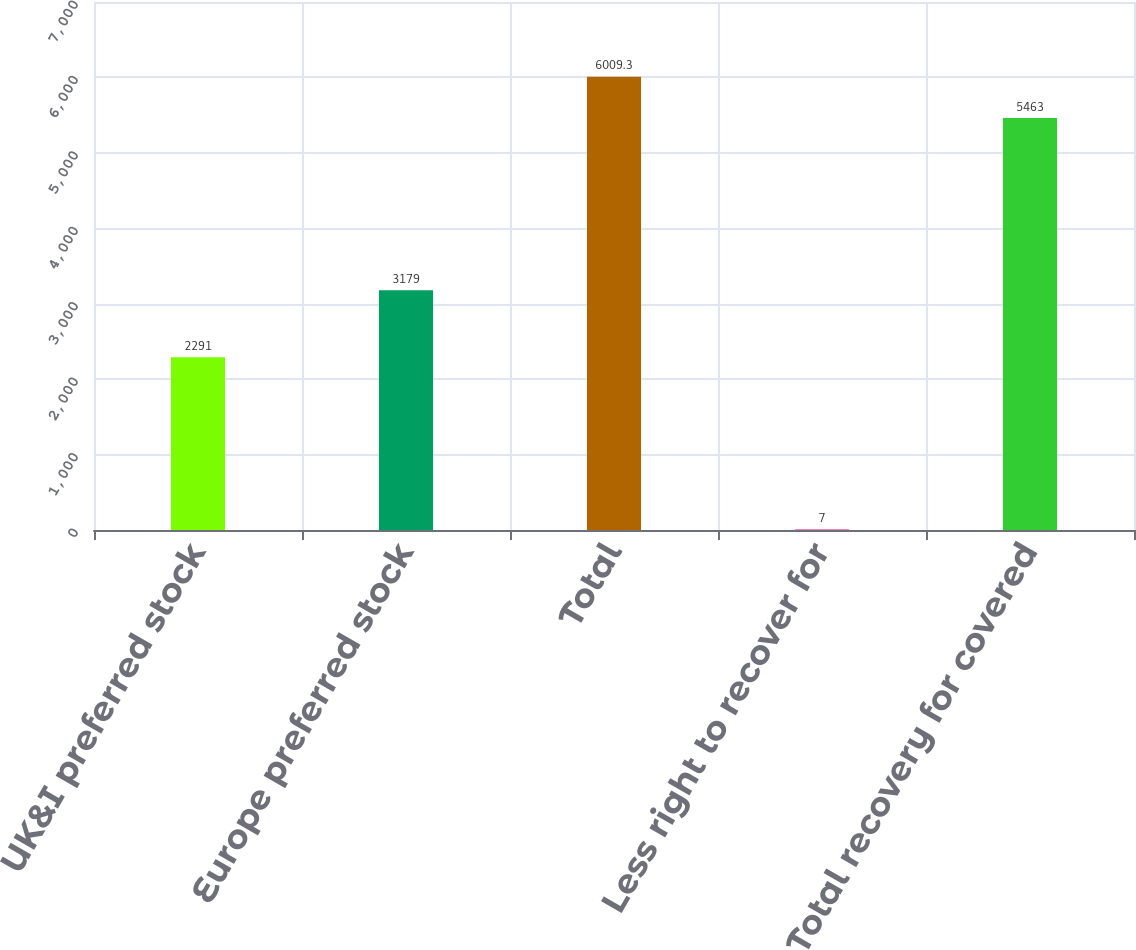<chart> <loc_0><loc_0><loc_500><loc_500><bar_chart><fcel>UK&I preferred stock<fcel>Europe preferred stock<fcel>Total<fcel>Less right to recover for<fcel>Total recovery for covered<nl><fcel>2291<fcel>3179<fcel>6009.3<fcel>7<fcel>5463<nl></chart> 